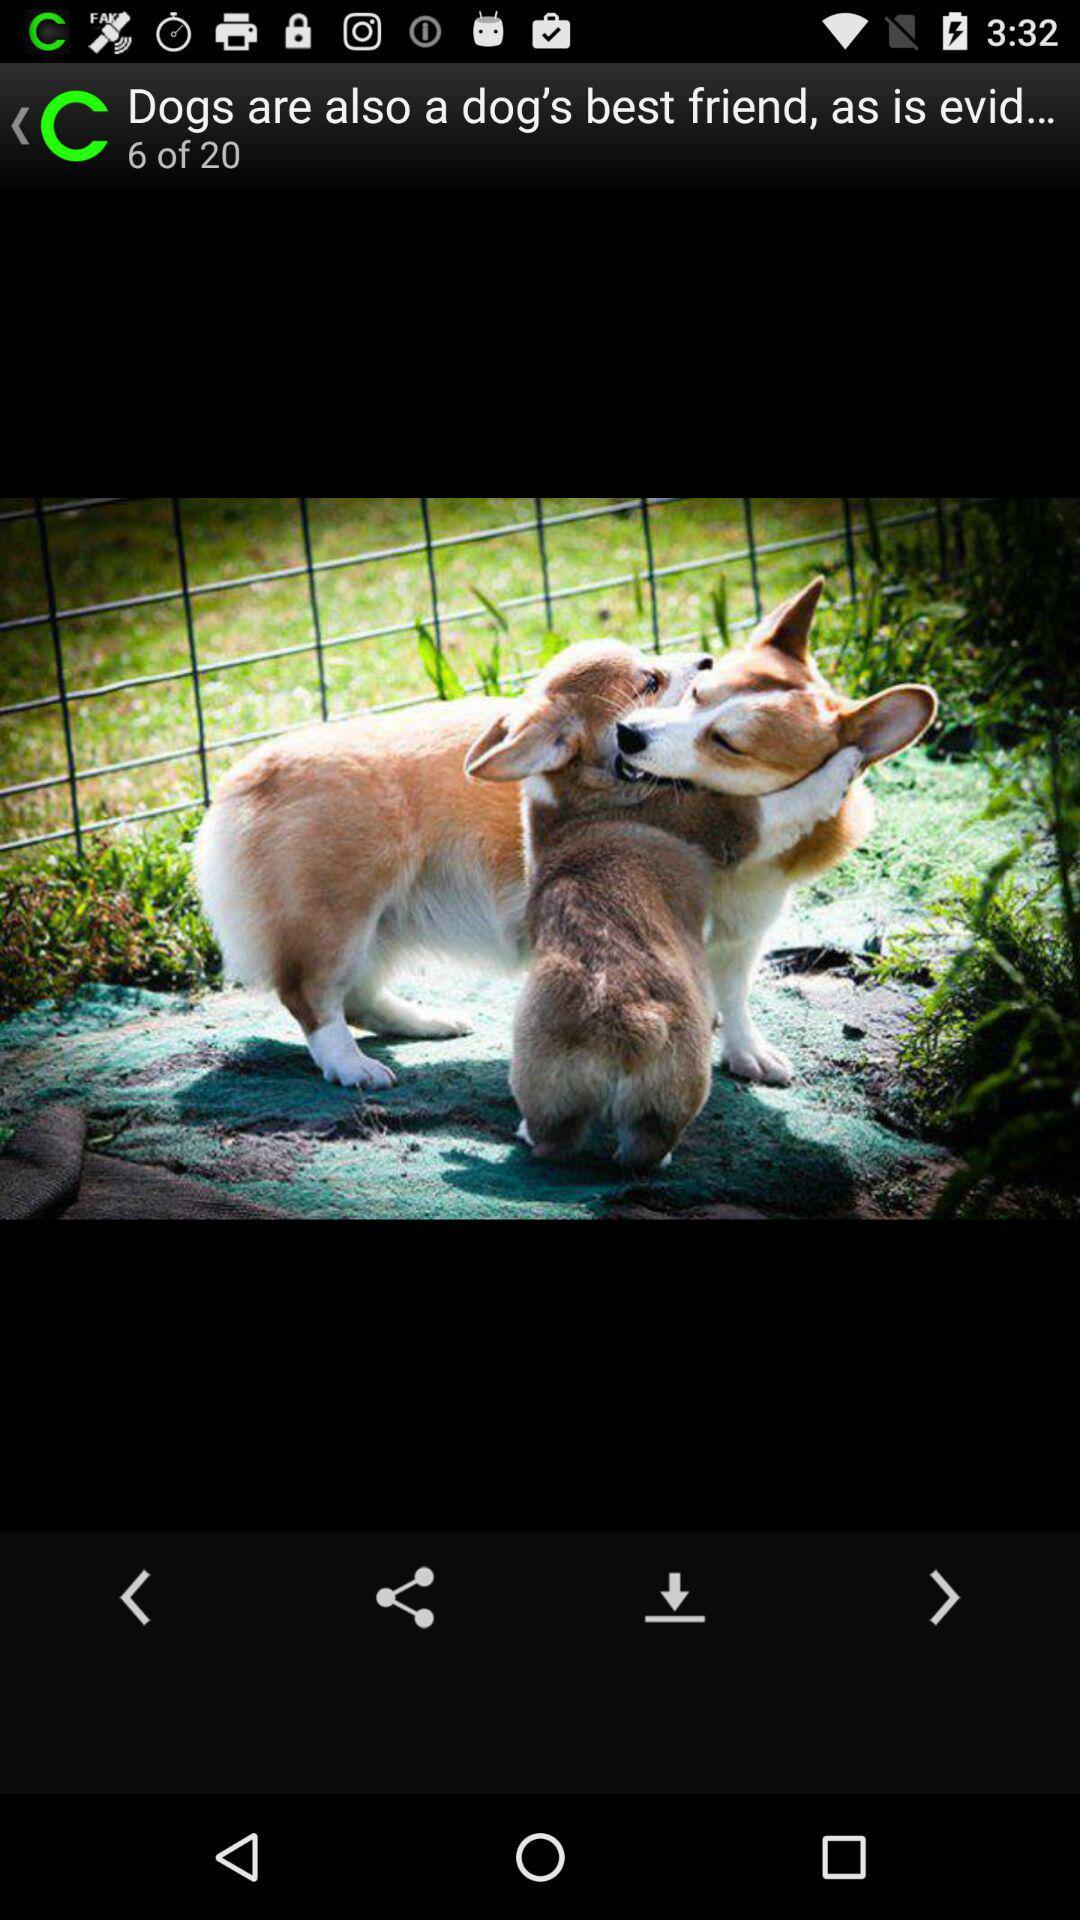How many images in total are there? There are 20 images in total. 